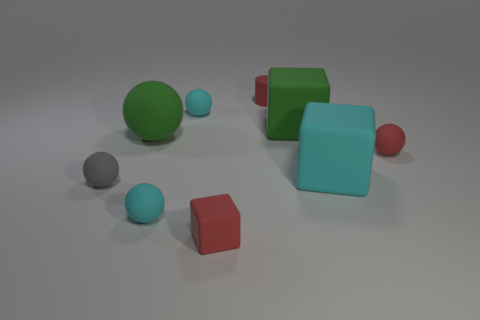There is a gray thing that is made of the same material as the tiny red block; what is its shape? The gray object in question is spherical, much like a small ball. Just like the tiny red block, it has a smooth surface, which likely indicates that both objects are made from a similar material, giving them a cohesive appearance in terms of texture. 